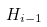<formula> <loc_0><loc_0><loc_500><loc_500>H _ { i - 1 }</formula> 